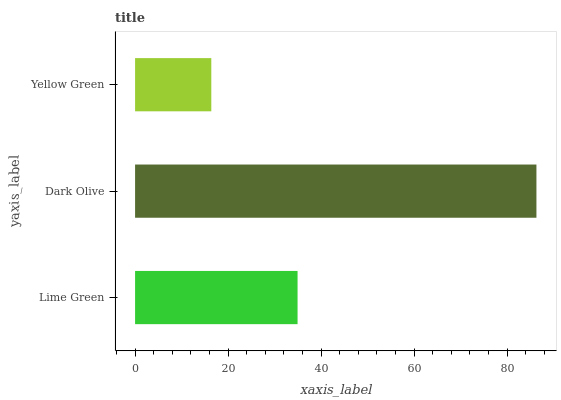Is Yellow Green the minimum?
Answer yes or no. Yes. Is Dark Olive the maximum?
Answer yes or no. Yes. Is Dark Olive the minimum?
Answer yes or no. No. Is Yellow Green the maximum?
Answer yes or no. No. Is Dark Olive greater than Yellow Green?
Answer yes or no. Yes. Is Yellow Green less than Dark Olive?
Answer yes or no. Yes. Is Yellow Green greater than Dark Olive?
Answer yes or no. No. Is Dark Olive less than Yellow Green?
Answer yes or no. No. Is Lime Green the high median?
Answer yes or no. Yes. Is Lime Green the low median?
Answer yes or no. Yes. Is Yellow Green the high median?
Answer yes or no. No. Is Dark Olive the low median?
Answer yes or no. No. 